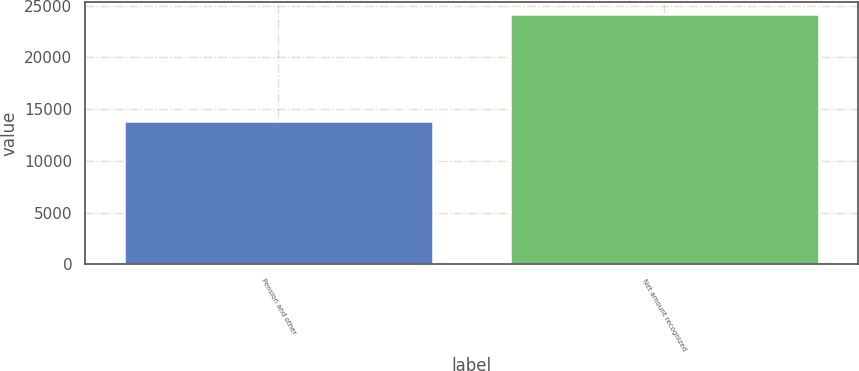Convert chart. <chart><loc_0><loc_0><loc_500><loc_500><bar_chart><fcel>Pension and other<fcel>Net amount recognized<nl><fcel>13813<fcel>24156<nl></chart> 